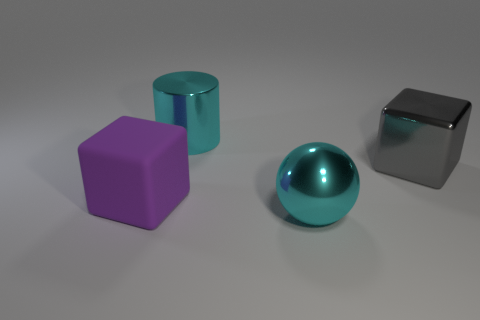What might be the purpose of this arrangement of objects? This arrangement of objects appears to be a deliberate composition meant to showcase a contrast in shapes and colors. It could serve an educational purpose like a demonstration of 3D rendering techniques or as a visual aid in understanding geometry and light interactions in physical spaces. 